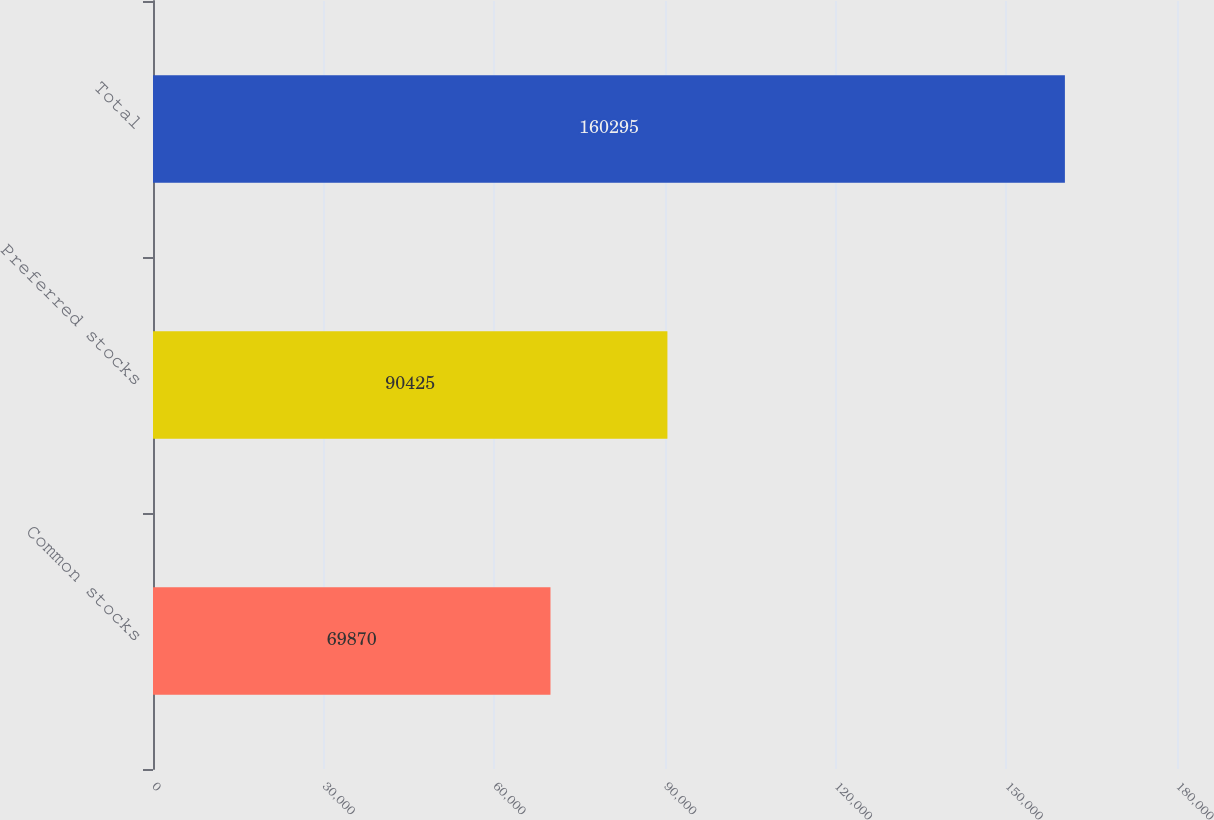Convert chart to OTSL. <chart><loc_0><loc_0><loc_500><loc_500><bar_chart><fcel>Common stocks<fcel>Preferred stocks<fcel>Total<nl><fcel>69870<fcel>90425<fcel>160295<nl></chart> 